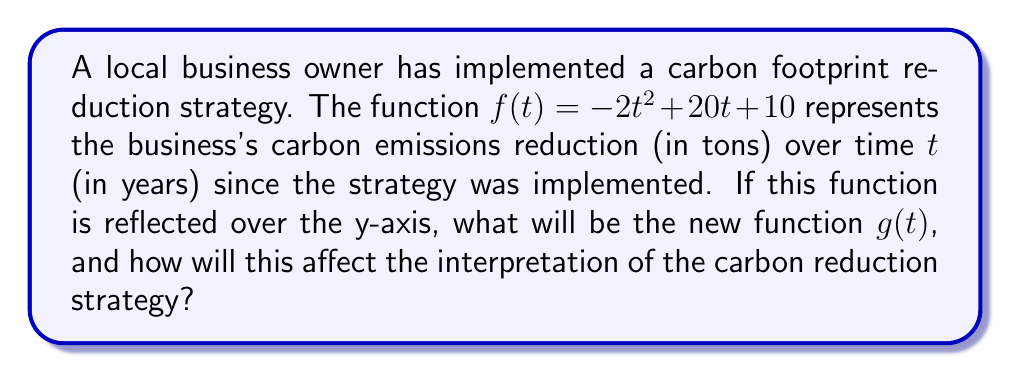Can you answer this question? To reflect a function over the y-axis, we replace every $t$ with $-t$ in the original function. This means:

1. Start with the original function: $f(t) = -2t^2 + 20t + 10$

2. Replace each $t$ with $-t$:
   $g(t) = -2(-t)^2 + 20(-t) + 10$

3. Simplify:
   $g(t) = -2t^2 - 20t + 10$

The new function $g(t) = -2t^2 - 20t + 10$ represents the reflection of $f(t)$ over the y-axis.

Interpretation:
- In the original function $f(t)$, as $t$ increases (moves to the right), the carbon reduction initially increases and then decreases due to the negative coefficient of $t^2$.
- In the reflected function $g(t)$, as $t$ increases, the carbon reduction immediately starts decreasing due to the negative coefficients of both $t^2$ and $t$ terms.
- The y-intercept (initial reduction) remains the same at 10 tons for both functions.
- The reflection essentially reverses the time axis, so $g(t)$ represents what would happen if time ran backwards from the implementation of the strategy.

For a business owner, this reflection might be used to analyze:
1. The potential impact if the reduction strategy had been implemented earlier.
2. How quickly the benefits of the strategy might diminish if efforts are not maintained.
3. The importance of continuous improvement in sustainability practices to maintain positive reduction trends.
Answer: The reflected function is $g(t) = -2t^2 - 20t + 10$. This reflection over the y-axis reverses the time progression of the carbon reduction strategy, potentially providing insights into earlier implementation or the consequences of not maintaining sustainability efforts. 